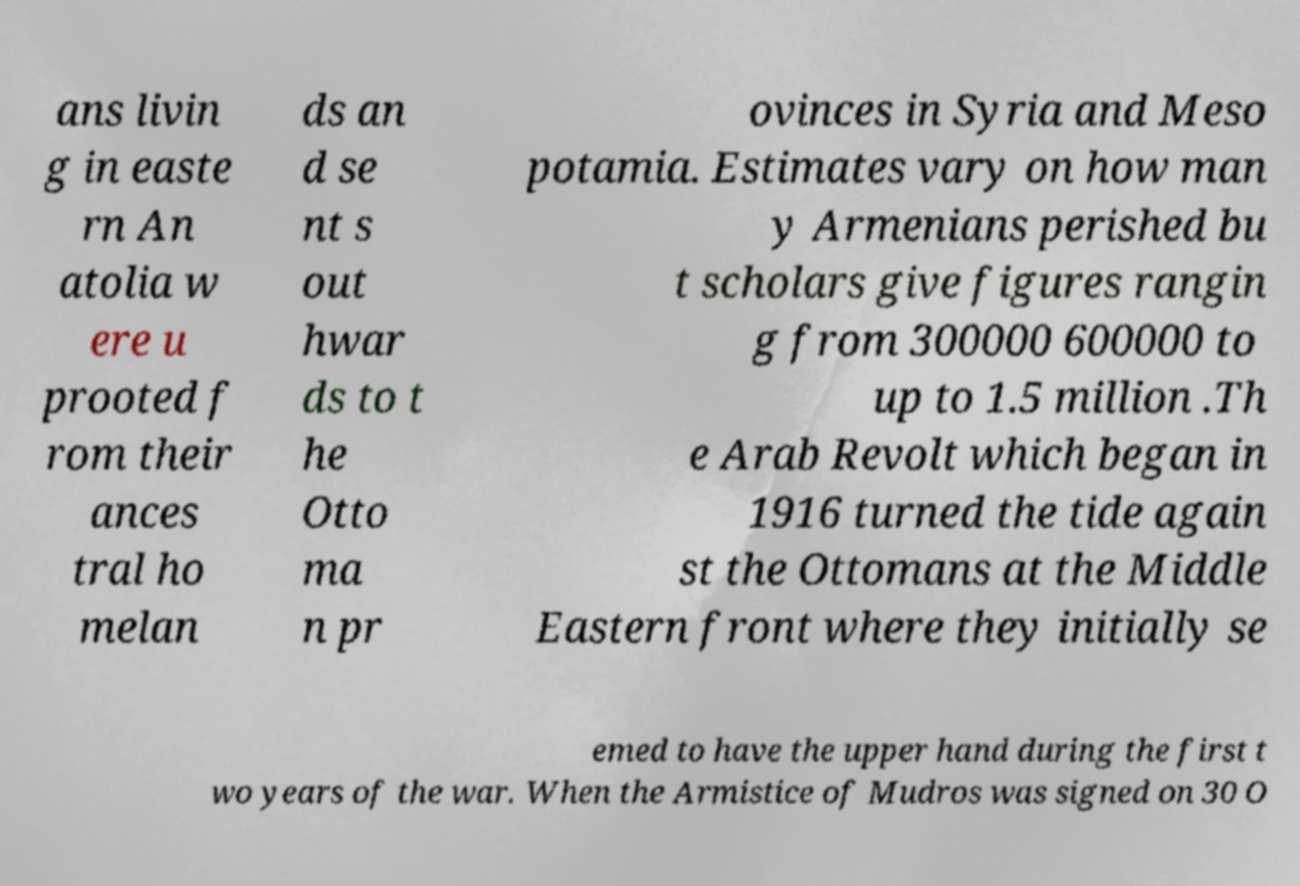Please identify and transcribe the text found in this image. ans livin g in easte rn An atolia w ere u prooted f rom their ances tral ho melan ds an d se nt s out hwar ds to t he Otto ma n pr ovinces in Syria and Meso potamia. Estimates vary on how man y Armenians perished bu t scholars give figures rangin g from 300000 600000 to up to 1.5 million .Th e Arab Revolt which began in 1916 turned the tide again st the Ottomans at the Middle Eastern front where they initially se emed to have the upper hand during the first t wo years of the war. When the Armistice of Mudros was signed on 30 O 